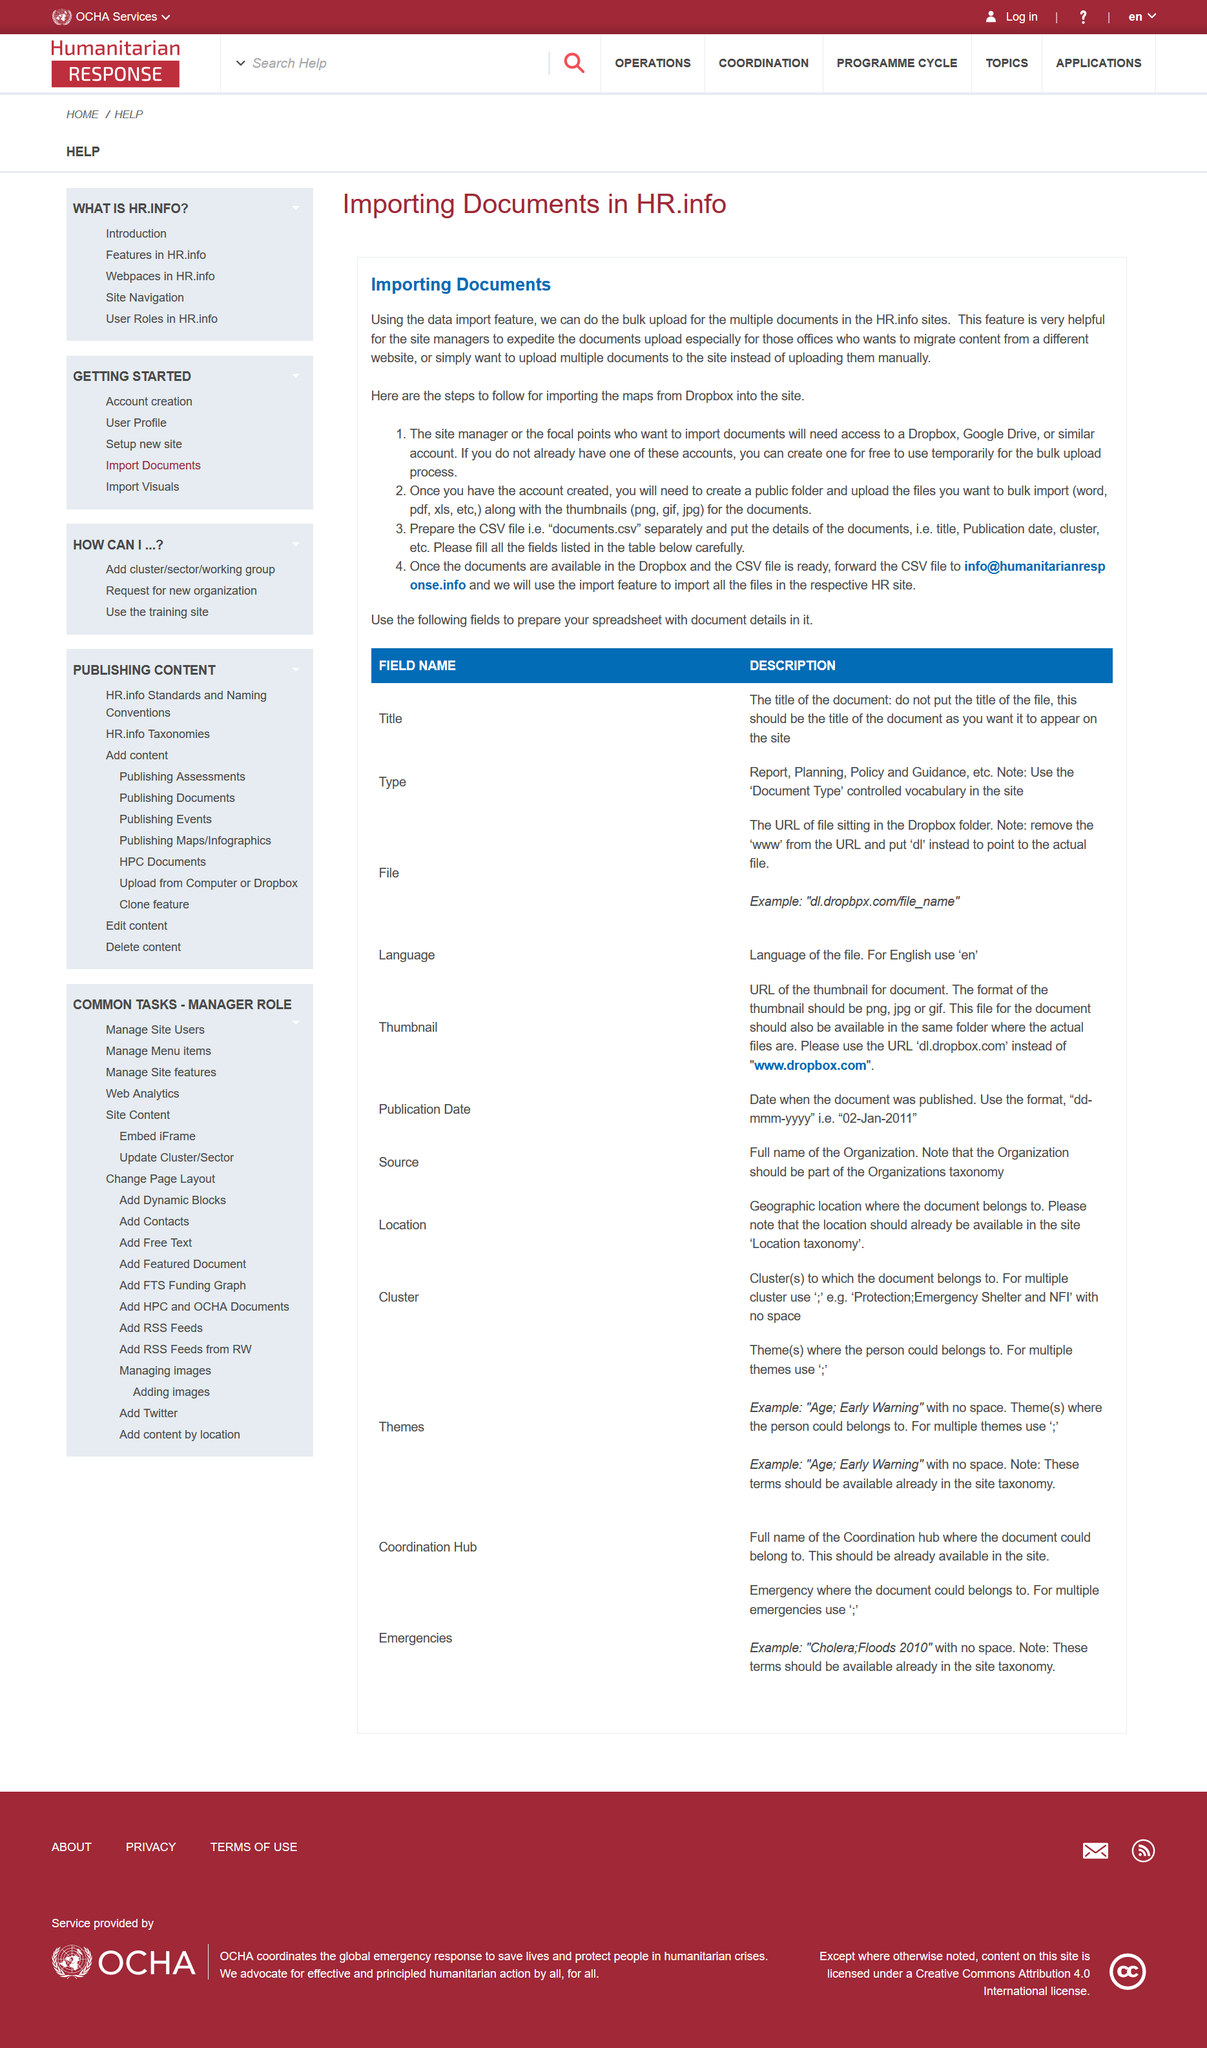Mention a couple of crucial points in this snapshot. Importing Documents is the topic discussed in this section. This section is titled 'Importing Documents in HR.info.' It is required to follow 3 steps. 